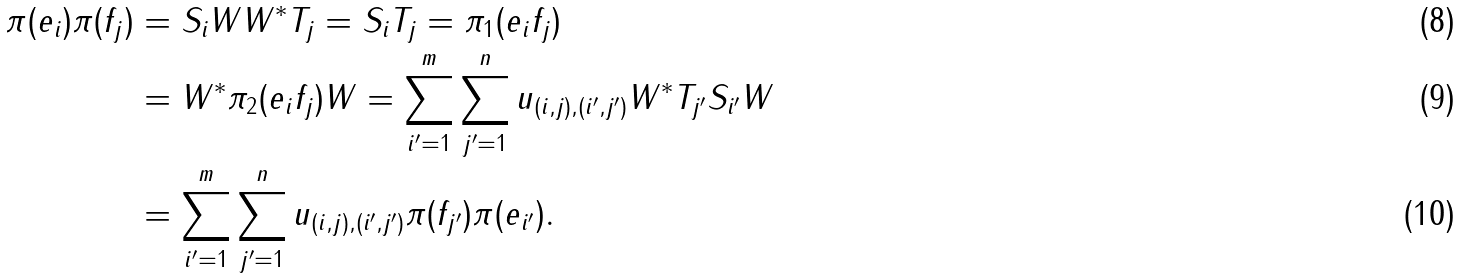<formula> <loc_0><loc_0><loc_500><loc_500>\pi ( e _ { i } ) \pi ( f _ { j } ) & = S _ { i } W W ^ { * } T _ { j } = S _ { i } T _ { j } = \pi _ { 1 } ( e _ { i } f _ { j } ) \\ & = W ^ { * } \pi _ { 2 } ( e _ { i } f _ { j } ) W = \sum _ { i ^ { \prime } = 1 } ^ { m } \sum _ { j ^ { \prime } = 1 } ^ { n } u _ { ( i , j ) , ( i ^ { \prime } , j ^ { \prime } ) } W ^ { * } T _ { j ^ { \prime } } S _ { i ^ { \prime } } W \\ & = \sum _ { i ^ { \prime } = 1 } ^ { m } \sum _ { j ^ { \prime } = 1 } ^ { n } u _ { ( i , j ) , ( i ^ { \prime } , j ^ { \prime } ) } \pi ( f _ { j ^ { \prime } } ) \pi ( e _ { i ^ { \prime } } ) .</formula> 